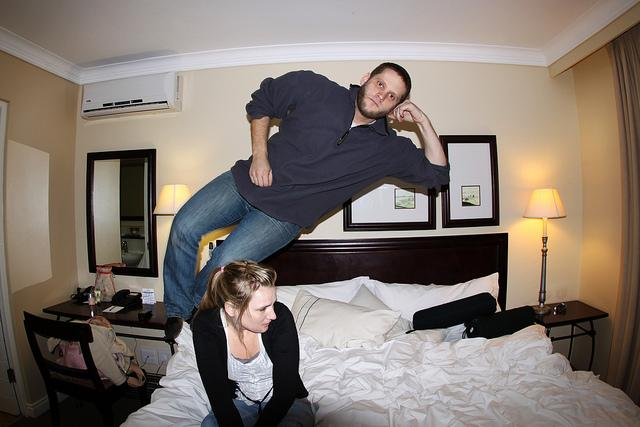Why does the man stand so strangely here?

Choices:
A) disoriented
B) posing
C) he's ill
D) having seizure posing 